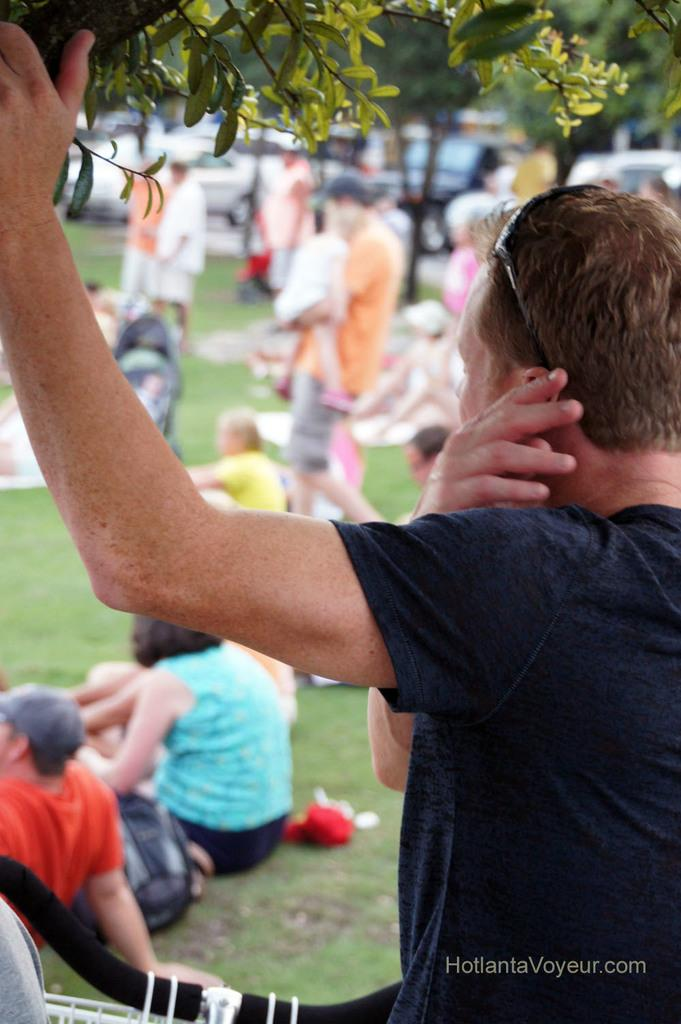What is the person in the image holding? The person is holding a branch of a tree in the image. What are the other people in the image doing? There are people standing and sitting on the grass in the image. Can you describe any objects related to transportation in the image? A bicycle handle is visible in the image, and there are also vehicles present. What type of shade does the tree provide in the image? There is no tree providing shade in the image; the person is holding a branch of a tree. 